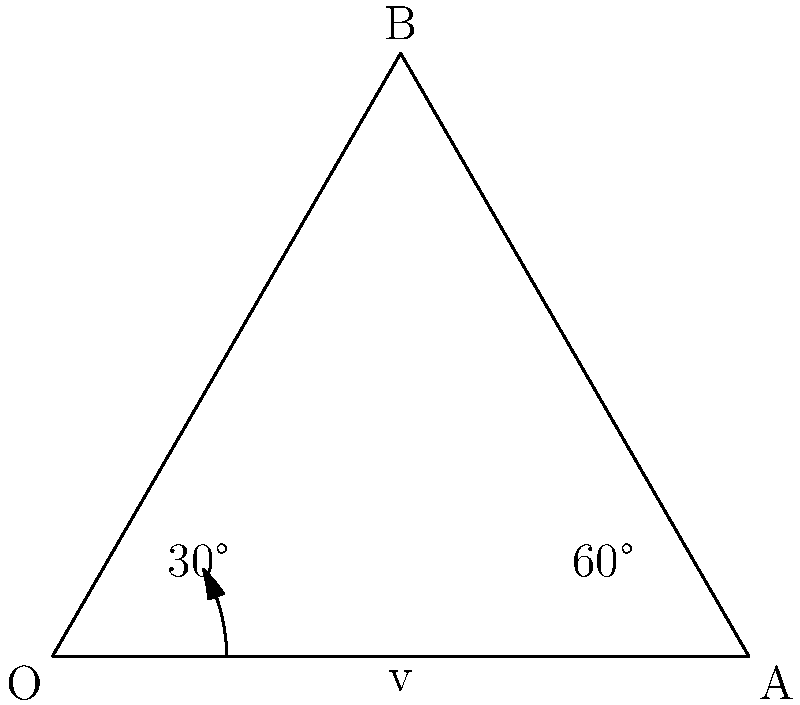In a 2D sports game simulation, a ball is moving horizontally with velocity $v$ and collides with a wall at a 60° angle. After the collision, the ball's new direction forms a 30° angle with the wall. Assuming perfect elasticity, what is the angle $\theta$ between the ball's initial and final velocity vectors? To solve this problem, we'll follow these steps:

1) In the diagram, OA represents the wall, OB is the initial velocity vector, and AB is the final velocity vector.

2) The angle between OA and OB is 60° (given).

3) The angle between OA and AB is 30° (given).

4) In an isosceles triangle, the base angles are equal. Since OA bisects angle BOA, triangle OAB is isosceles, with OB = AB.

5) The angle BOA is the sum of the two given angles: 60° + 30° = 90°.

6) In an isosceles right triangle, the two non-right angles are each 45°.

7) Therefore, angle ABO (which we're looking for) is 45°.

8) The angle $\theta$ between the initial and final velocity vectors is the supplement of angle ABO:

   $\theta = 180° - 45° = 135°$

Thus, the angle between the ball's initial and final velocity vectors is 135°.
Answer: 135° 